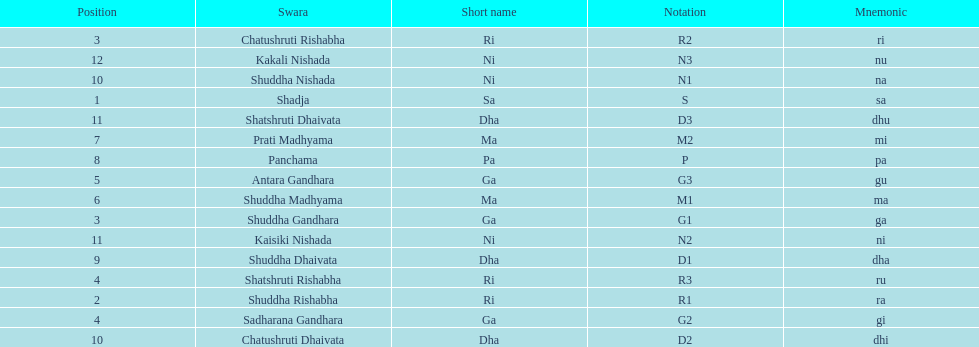On average how many of the swara have a short name that begin with d or g? 6. 